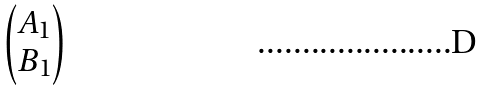<formula> <loc_0><loc_0><loc_500><loc_500>\begin{pmatrix} A _ { 1 } \\ B _ { 1 } \end{pmatrix}</formula> 